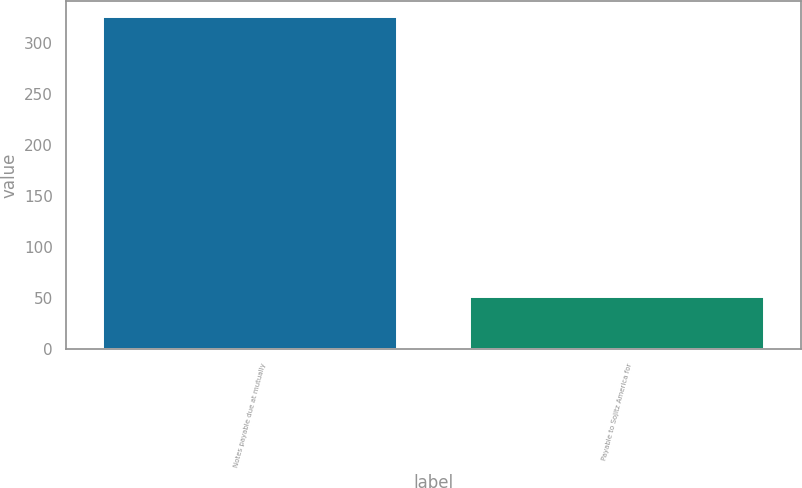Convert chart to OTSL. <chart><loc_0><loc_0><loc_500><loc_500><bar_chart><fcel>Notes payable due at mutually<fcel>Payable to Sojitz America for<nl><fcel>325<fcel>51<nl></chart> 